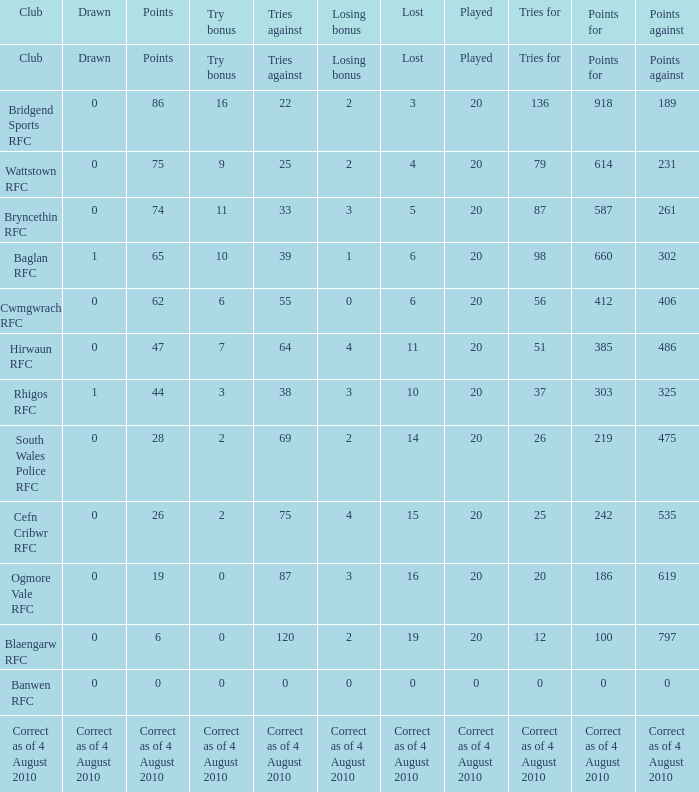What is the tries fow when losing bonus is losing bonus? Tries for. 